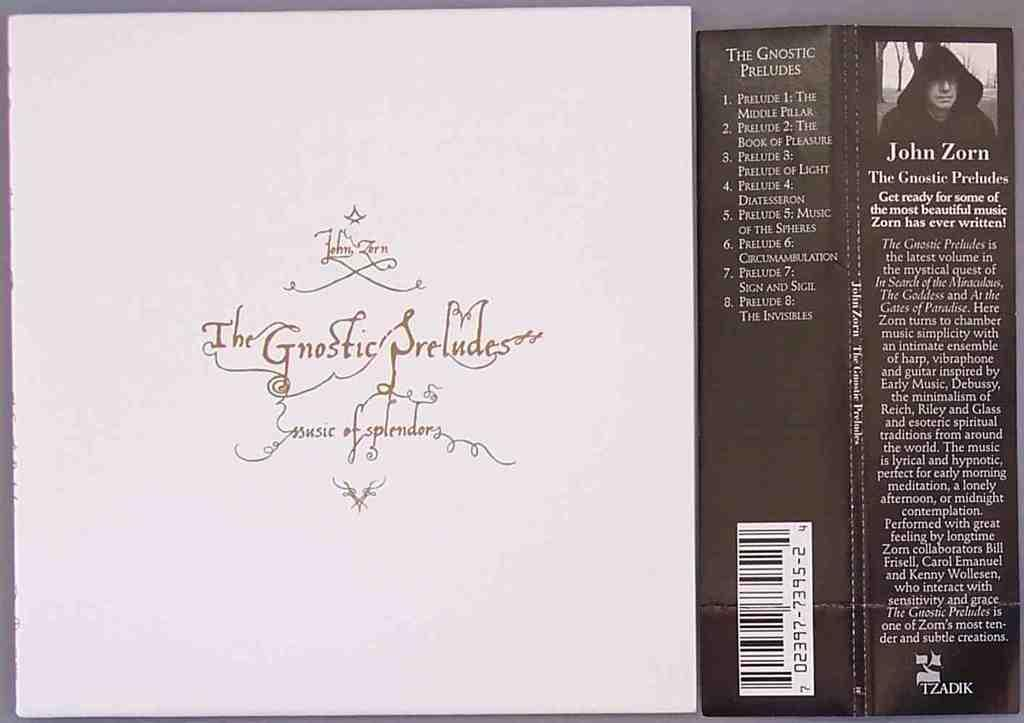What objects are present in the image? There are boards in the image. What is depicted on the boards? There is a person depicted on the boards. What else can be seen on the boards? There is text on the boards. How many fingers can be seen on the person depicted on the boards? There are no fingers visible on the person depicted on the boards, as it is likely a two-dimensional image. 